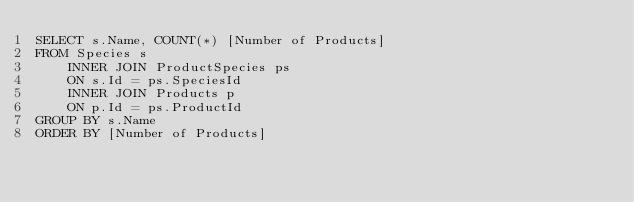<code> <loc_0><loc_0><loc_500><loc_500><_SQL_>SELECT s.Name, COUNT(*) [Number of Products]
FROM Species s
	INNER JOIN ProductSpecies ps
	ON s.Id = ps.SpeciesId
	INNER JOIN Products p
	ON p.Id = ps.ProductId
GROUP BY s.Name
ORDER BY [Number of Products] </code> 